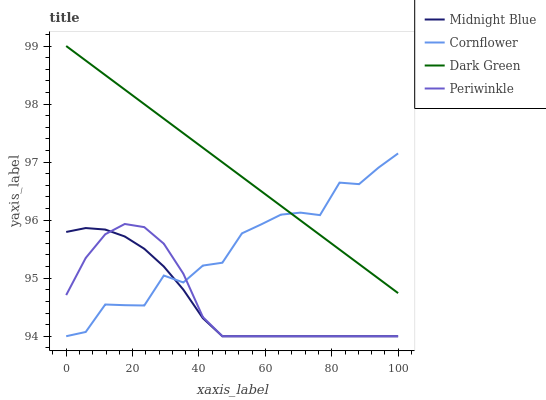Does Midnight Blue have the minimum area under the curve?
Answer yes or no. Yes. Does Dark Green have the maximum area under the curve?
Answer yes or no. Yes. Does Periwinkle have the minimum area under the curve?
Answer yes or no. No. Does Periwinkle have the maximum area under the curve?
Answer yes or no. No. Is Dark Green the smoothest?
Answer yes or no. Yes. Is Cornflower the roughest?
Answer yes or no. Yes. Is Periwinkle the smoothest?
Answer yes or no. No. Is Periwinkle the roughest?
Answer yes or no. No. Does Periwinkle have the lowest value?
Answer yes or no. Yes. Does Dark Green have the lowest value?
Answer yes or no. No. Does Dark Green have the highest value?
Answer yes or no. Yes. Does Periwinkle have the highest value?
Answer yes or no. No. Is Periwinkle less than Dark Green?
Answer yes or no. Yes. Is Dark Green greater than Midnight Blue?
Answer yes or no. Yes. Does Periwinkle intersect Midnight Blue?
Answer yes or no. Yes. Is Periwinkle less than Midnight Blue?
Answer yes or no. No. Is Periwinkle greater than Midnight Blue?
Answer yes or no. No. Does Periwinkle intersect Dark Green?
Answer yes or no. No. 